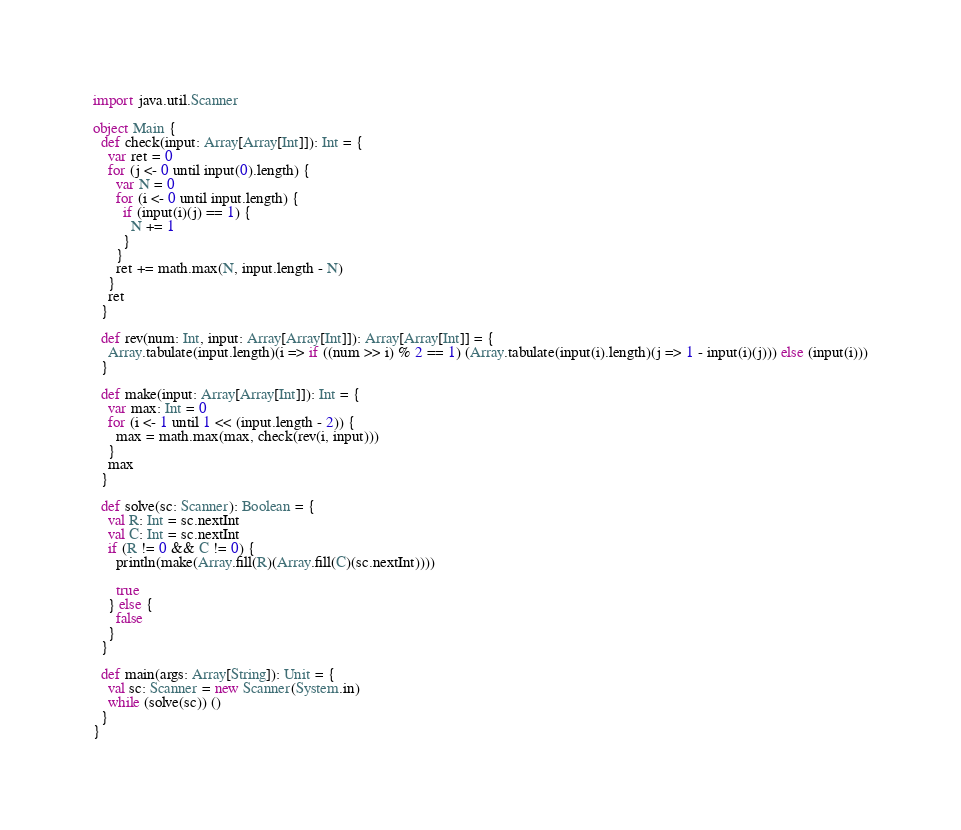<code> <loc_0><loc_0><loc_500><loc_500><_Scala_>import java.util.Scanner

object Main {
  def check(input: Array[Array[Int]]): Int = {
    var ret = 0
    for (j <- 0 until input(0).length) {
      var N = 0
      for (i <- 0 until input.length) {
        if (input(i)(j) == 1) {
          N += 1
        }
      }
      ret += math.max(N, input.length - N)
    }
    ret
  }

  def rev(num: Int, input: Array[Array[Int]]): Array[Array[Int]] = {
    Array.tabulate(input.length)(i => if ((num >> i) % 2 == 1) (Array.tabulate(input(i).length)(j => 1 - input(i)(j))) else (input(i)))
  }

  def make(input: Array[Array[Int]]): Int = {
    var max: Int = 0
    for (i <- 1 until 1 << (input.length - 2)) {
      max = math.max(max, check(rev(i, input)))
    }
    max
  }

  def solve(sc: Scanner): Boolean = {
    val R: Int = sc.nextInt
    val C: Int = sc.nextInt
    if (R != 0 && C != 0) {
      println(make(Array.fill(R)(Array.fill(C)(sc.nextInt))))

      true
    } else {
      false
    }
  }

  def main(args: Array[String]): Unit = {
    val sc: Scanner = new Scanner(System.in)
    while (solve(sc)) ()
  }
}</code> 